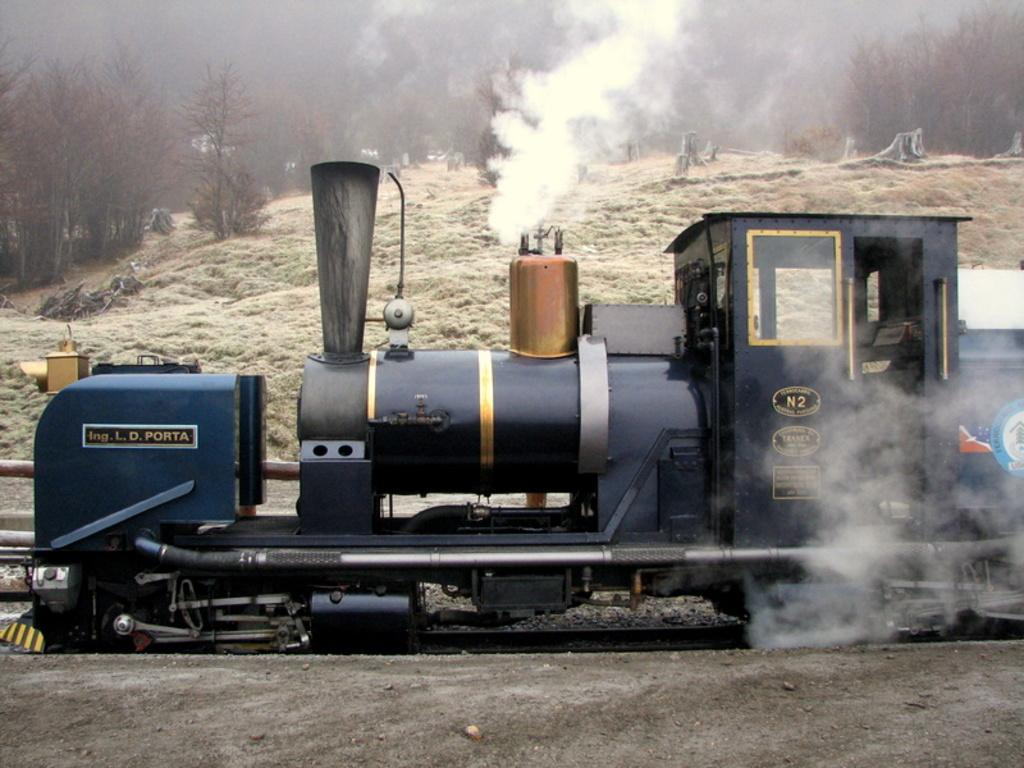What is the main subject of the image? The main subject of the image is an engine of the rail. Can you describe any text on the engine? Yes, there is text written on the engine. What can be seen in the background of the image? There are trees in the background of the image. What is the visible smoke in the image associated with? The smoke is associated with the engine, likely from its operation. What type of arithmetic problem is being solved by the engine in the image? There is no arithmetic problem being solved by the engine in the image; it is a mode of transportation and not a sentient being capable of solving mathematical problems. 